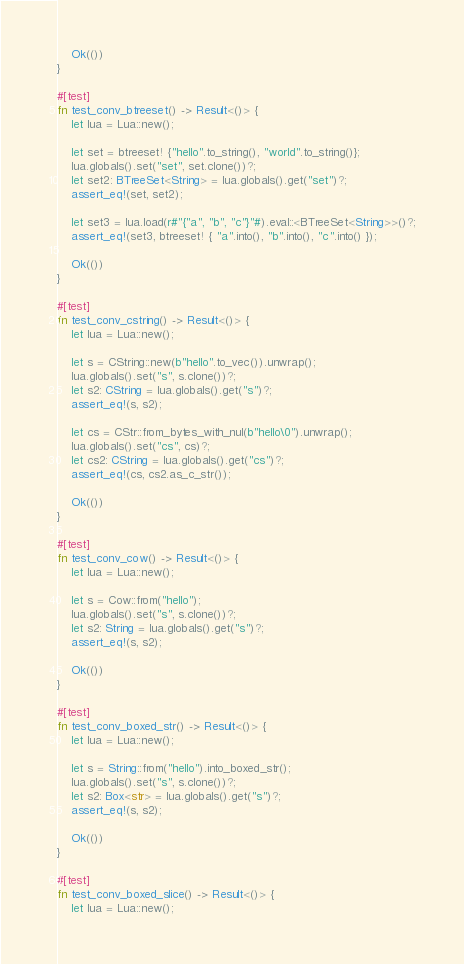<code> <loc_0><loc_0><loc_500><loc_500><_Rust_>    Ok(())
}

#[test]
fn test_conv_btreeset() -> Result<()> {
    let lua = Lua::new();

    let set = btreeset! {"hello".to_string(), "world".to_string()};
    lua.globals().set("set", set.clone())?;
    let set2: BTreeSet<String> = lua.globals().get("set")?;
    assert_eq!(set, set2);

    let set3 = lua.load(r#"{"a", "b", "c"}"#).eval::<BTreeSet<String>>()?;
    assert_eq!(set3, btreeset! { "a".into(), "b".into(), "c".into() });

    Ok(())
}

#[test]
fn test_conv_cstring() -> Result<()> {
    let lua = Lua::new();

    let s = CString::new(b"hello".to_vec()).unwrap();
    lua.globals().set("s", s.clone())?;
    let s2: CString = lua.globals().get("s")?;
    assert_eq!(s, s2);

    let cs = CStr::from_bytes_with_nul(b"hello\0").unwrap();
    lua.globals().set("cs", cs)?;
    let cs2: CString = lua.globals().get("cs")?;
    assert_eq!(cs, cs2.as_c_str());

    Ok(())
}

#[test]
fn test_conv_cow() -> Result<()> {
    let lua = Lua::new();

    let s = Cow::from("hello");
    lua.globals().set("s", s.clone())?;
    let s2: String = lua.globals().get("s")?;
    assert_eq!(s, s2);

    Ok(())
}

#[test]
fn test_conv_boxed_str() -> Result<()> {
    let lua = Lua::new();

    let s = String::from("hello").into_boxed_str();
    lua.globals().set("s", s.clone())?;
    let s2: Box<str> = lua.globals().get("s")?;
    assert_eq!(s, s2);

    Ok(())
}

#[test]
fn test_conv_boxed_slice() -> Result<()> {
    let lua = Lua::new();
</code> 